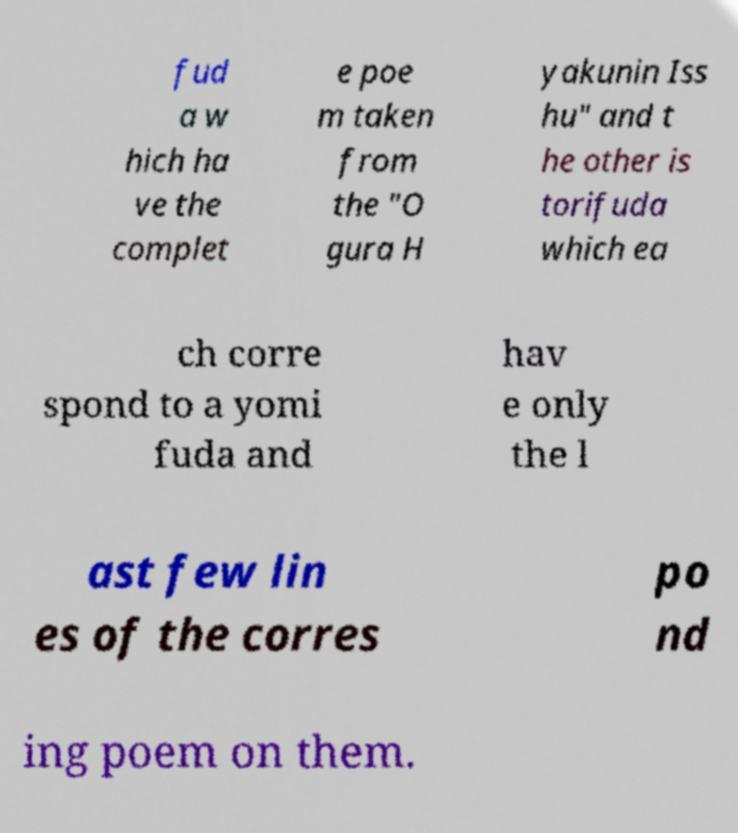Could you assist in decoding the text presented in this image and type it out clearly? fud a w hich ha ve the complet e poe m taken from the "O gura H yakunin Iss hu" and t he other is torifuda which ea ch corre spond to a yomi fuda and hav e only the l ast few lin es of the corres po nd ing poem on them. 